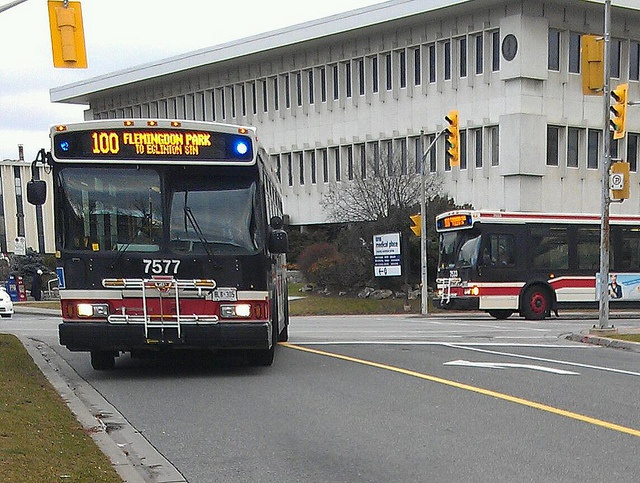Describe the objects in this image and their specific colors. I can see bus in ivory, black, gray, darkgray, and maroon tones, bus in ivory, black, gray, lightgray, and darkgray tones, traffic light in ivory, orange, white, and olive tones, traffic light in ivory, olive, orange, tan, and gray tones, and traffic light in ivory, orange, black, and olive tones in this image. 